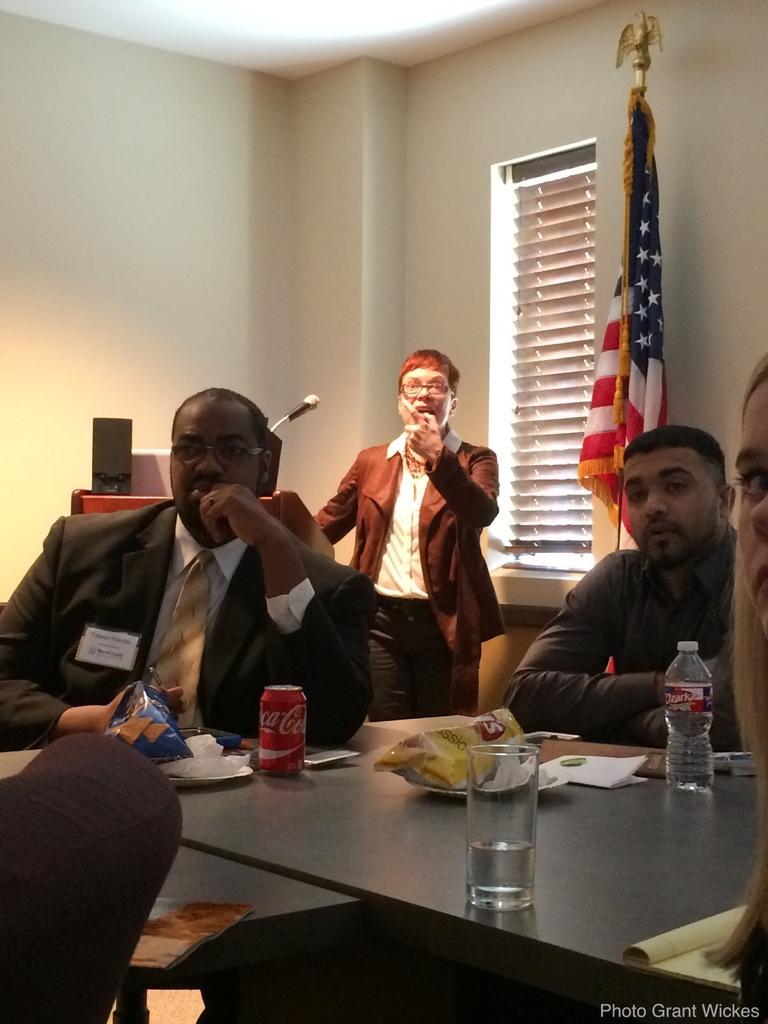Describe this image in one or two sentences. In the middle of the image a man is standing. In front of him there is a podium and there is a microphone. Bottom right side of the image there is a table on the table there is a glass, bottle, papers, tin and food products. Surrounding the table few people are sitting on chairs. Top right side of the image there is a flag. Behind the flag there is a wall on the wall there is a window. At the top of the image there is a roof. 